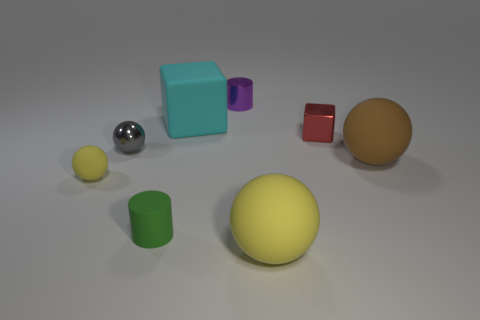Considering the various objects and their colors, what could this image represent or be used for? This image appears to be a composition of 3D-rendered geometric shapes with various materials and colors. It could represent a digital art piece, a visual aid for educational purposes to teach about shapes and volumes, or even a simple test scene for testing rendering techniques in computer graphics. 